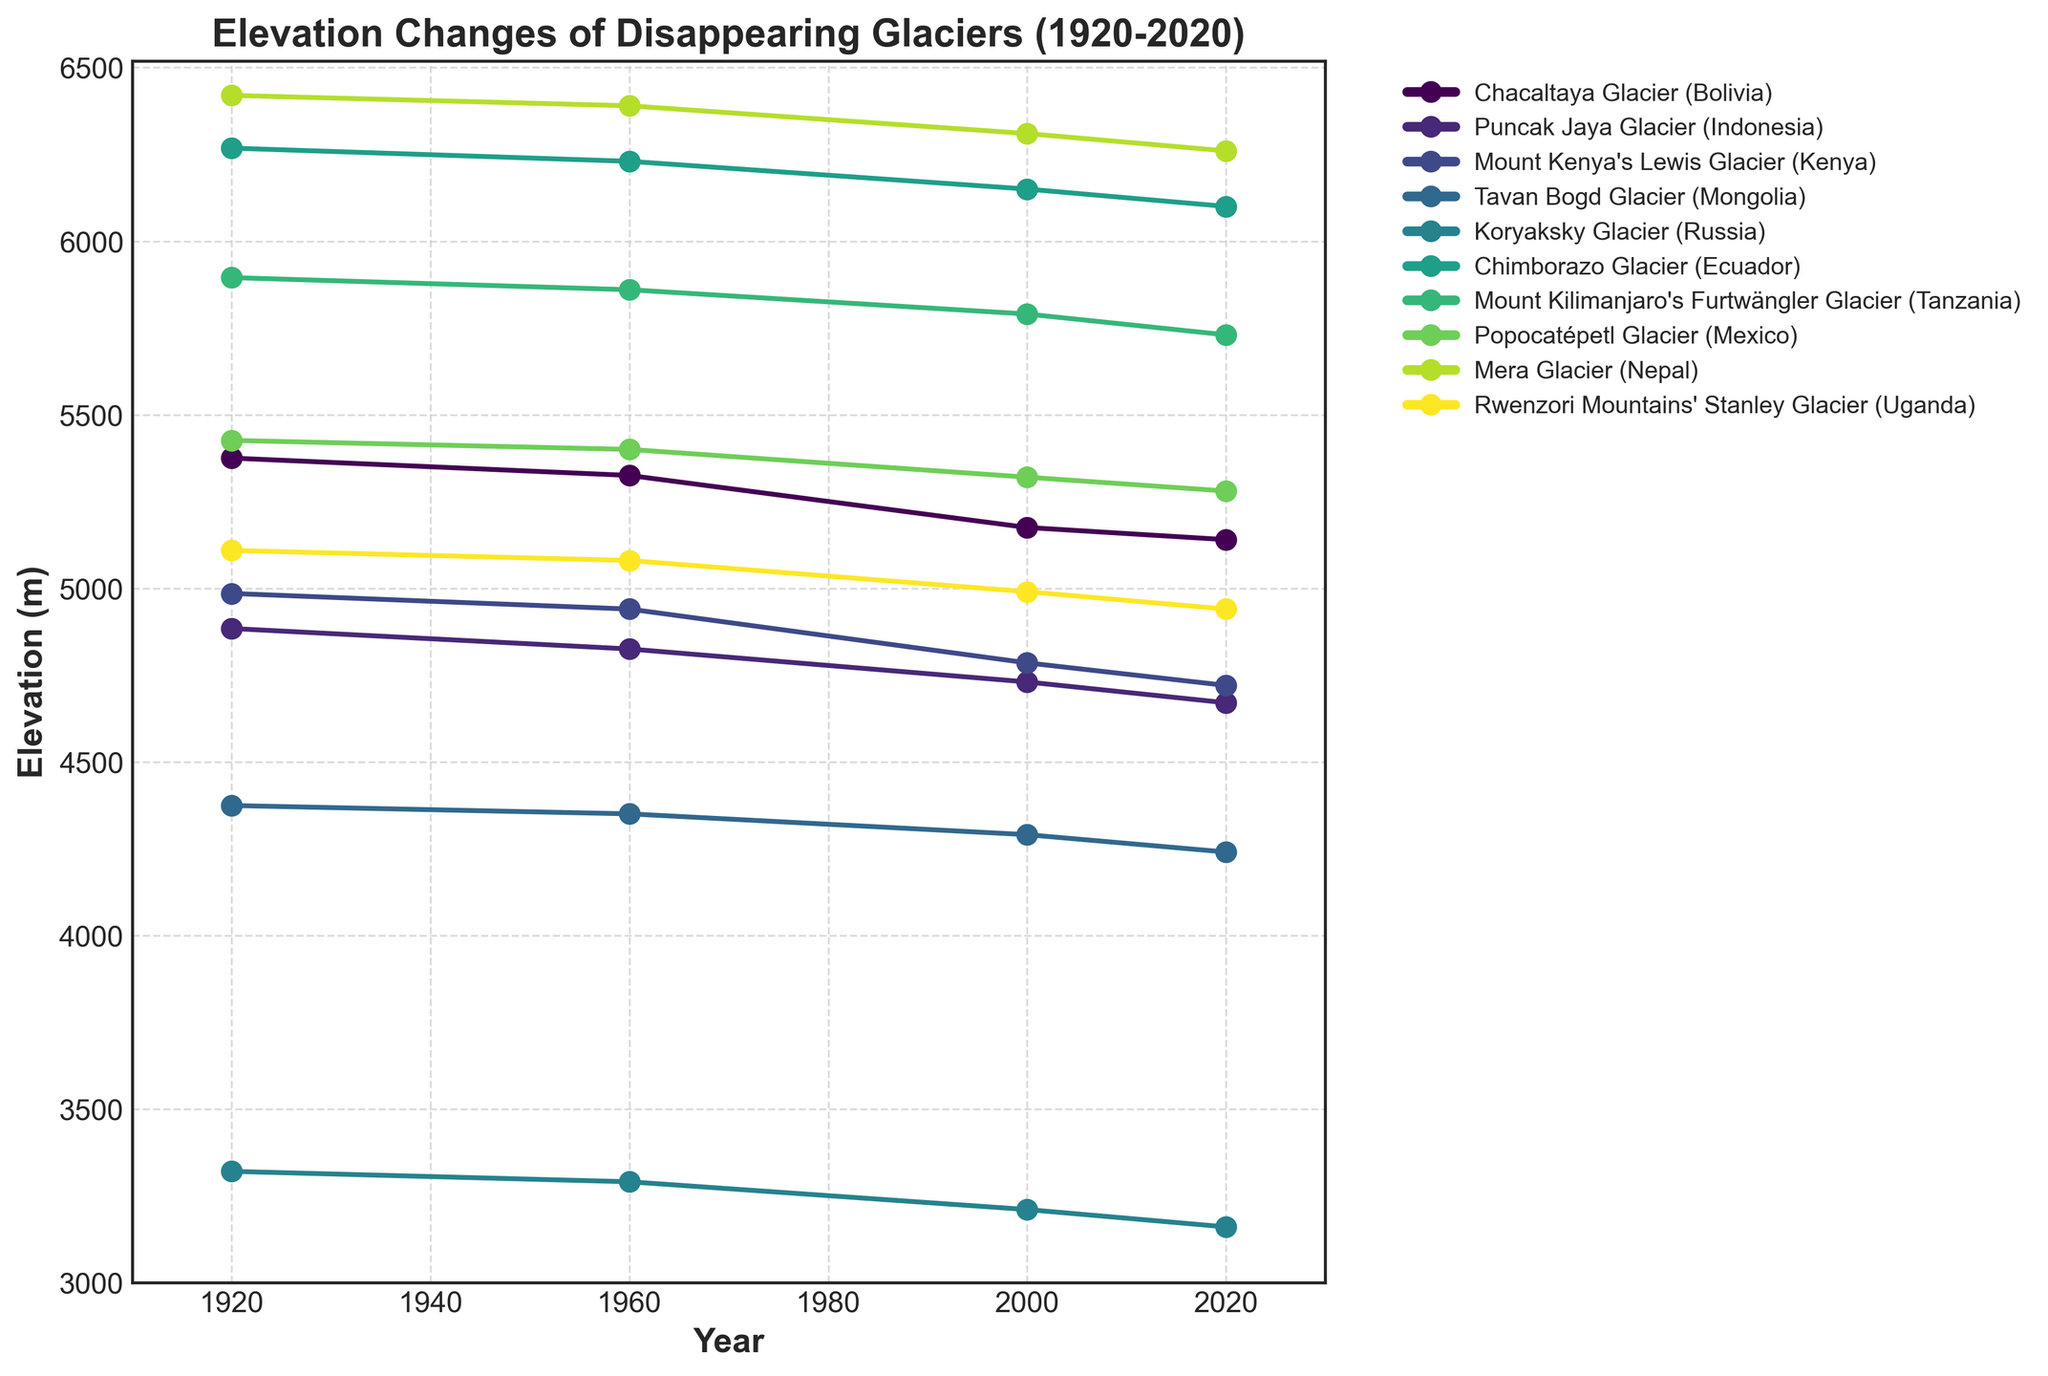Which glacier shows the highest elevation throughout the century? By observing the line graph, identify the glacier line that consistently maintains the highest elevation values from 1920 to 2020. This is the glacier with the highest starting point and the smallest decline relative to others.
Answer: Mera Glacier (Nepal) Which glacier experienced the largest decrease in elevation from 1920 to 2020? Calculate the difference in elevation for each glacier between 1920 and 2020. The glacier with the greatest difference has experienced the largest decrease. For example, the Chacaltaya Glacier (Bolivia) went from 5375 m in 1920 to 5140 m in 2020, a decrease of 235 m. Perform similar calculations for all glaciers and find the maximum.
Answer: Puncak Jaya Glacier (Indonesia) Which two glaciers had the most similar elevation changes over the century? Look for two lines on the graph that have closely matching trends or nearly parallel lines from 1920 to 2020. This means that their elevation values decrease at similar rates over time. Confirm by checking their respective numerical data points.
Answer: Rwenzori Mountains' Stanley Glacier (Uganda) and Mount Kenya's Lewis Glacier (Kenya) Between 2000 and 2020, which glacier's elevation decreased the most? Focus on the segment of the graph between the years 2000 and 2020. Calculate the difference in elevation for each glacier during this period. Identify the glacier with the largest decrease. E.g., for the Puncak Jaya Glacier (Indonesia), subtract the 2020 value (4670 m) from the 2000 value (4730 m) to get a decrease of 60 m. Perform the same for all glaciers and find the maximum difference.
Answer: Puncak Jaya Glacier (Indonesia) How many glaciers had an elevation above 5000 m in 1960? Identify the elevation values for each glacier in the year 1960. Count the number of glaciers with these elevation values exceeding 5000 m.
Answer: 6 Which glacier shows the steepest decline between any two consecutive points? Observe the slopes of the lines connecting each pair of consecutive points for each glacier. The steepest decline is represented by the line segment with the largest negative slope. For example, calculate the absolute difference between elevation values between every consecutive pair of years for each glacier, and find the maximum difference.
Answer: Puncak Jaya Glacier (Indonesia) between 1960 and 2000 Compare the elevation change of Chimborazo Glacier (Ecuador) and Mount Kilimanjaro's Furtwängler Glacier (Tanzania) from 1920 to 2020. Which one lost more elevation? Subtract the 2020 elevation from the 1920 elevation for each glacier to find the total elevation loss. Chimborazo lost 168 m (6268 - 6100) while Mount Kilimanjaro lost 165 m (5895 - 5730). Compare these differences to determine which is larger.
Answer: Chimborazo Glacier (Ecuador) Among all glaciers, what is the average elevation in 2000? Sum the elevation values for all glaciers in the year 2000 and divide by the number of glaciers. (5175 + 4730 + 4785 + 4290 + 3210 + 6150 + 5790 + 5320 + 6310 + 4990) / 10 = 5075 m.
Answer: 5075 m What is the elevation difference between the highest and lowest glacier in 2020? Identify the highest and lowest elevation values in the year 2020 from the graph. Subtract the lowest value from the highest value, e.g., Mera Glacier (6260 m) - Koryaksky Glacier (3160 m) = 3100 m.
Answer: 3100 m 